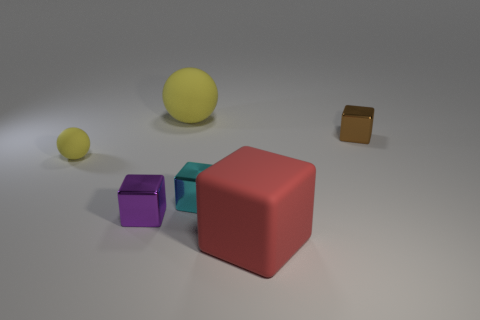Add 3 big cubes. How many objects exist? 9 Subtract all purple cubes. How many cubes are left? 3 Subtract 1 balls. How many balls are left? 1 Subtract all red cubes. How many cubes are left? 3 Subtract all blue cubes. Subtract all gray balls. How many cubes are left? 4 Subtract all tiny brown shiny objects. Subtract all green rubber cylinders. How many objects are left? 5 Add 1 cyan cubes. How many cyan cubes are left? 2 Add 1 large matte balls. How many large matte balls exist? 2 Subtract 0 gray cylinders. How many objects are left? 6 Subtract all balls. How many objects are left? 4 